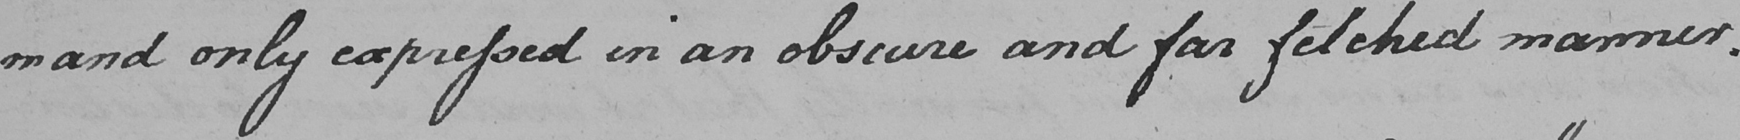What text is written in this handwritten line? -mand only expressed in an obscure and far fetched manner . 